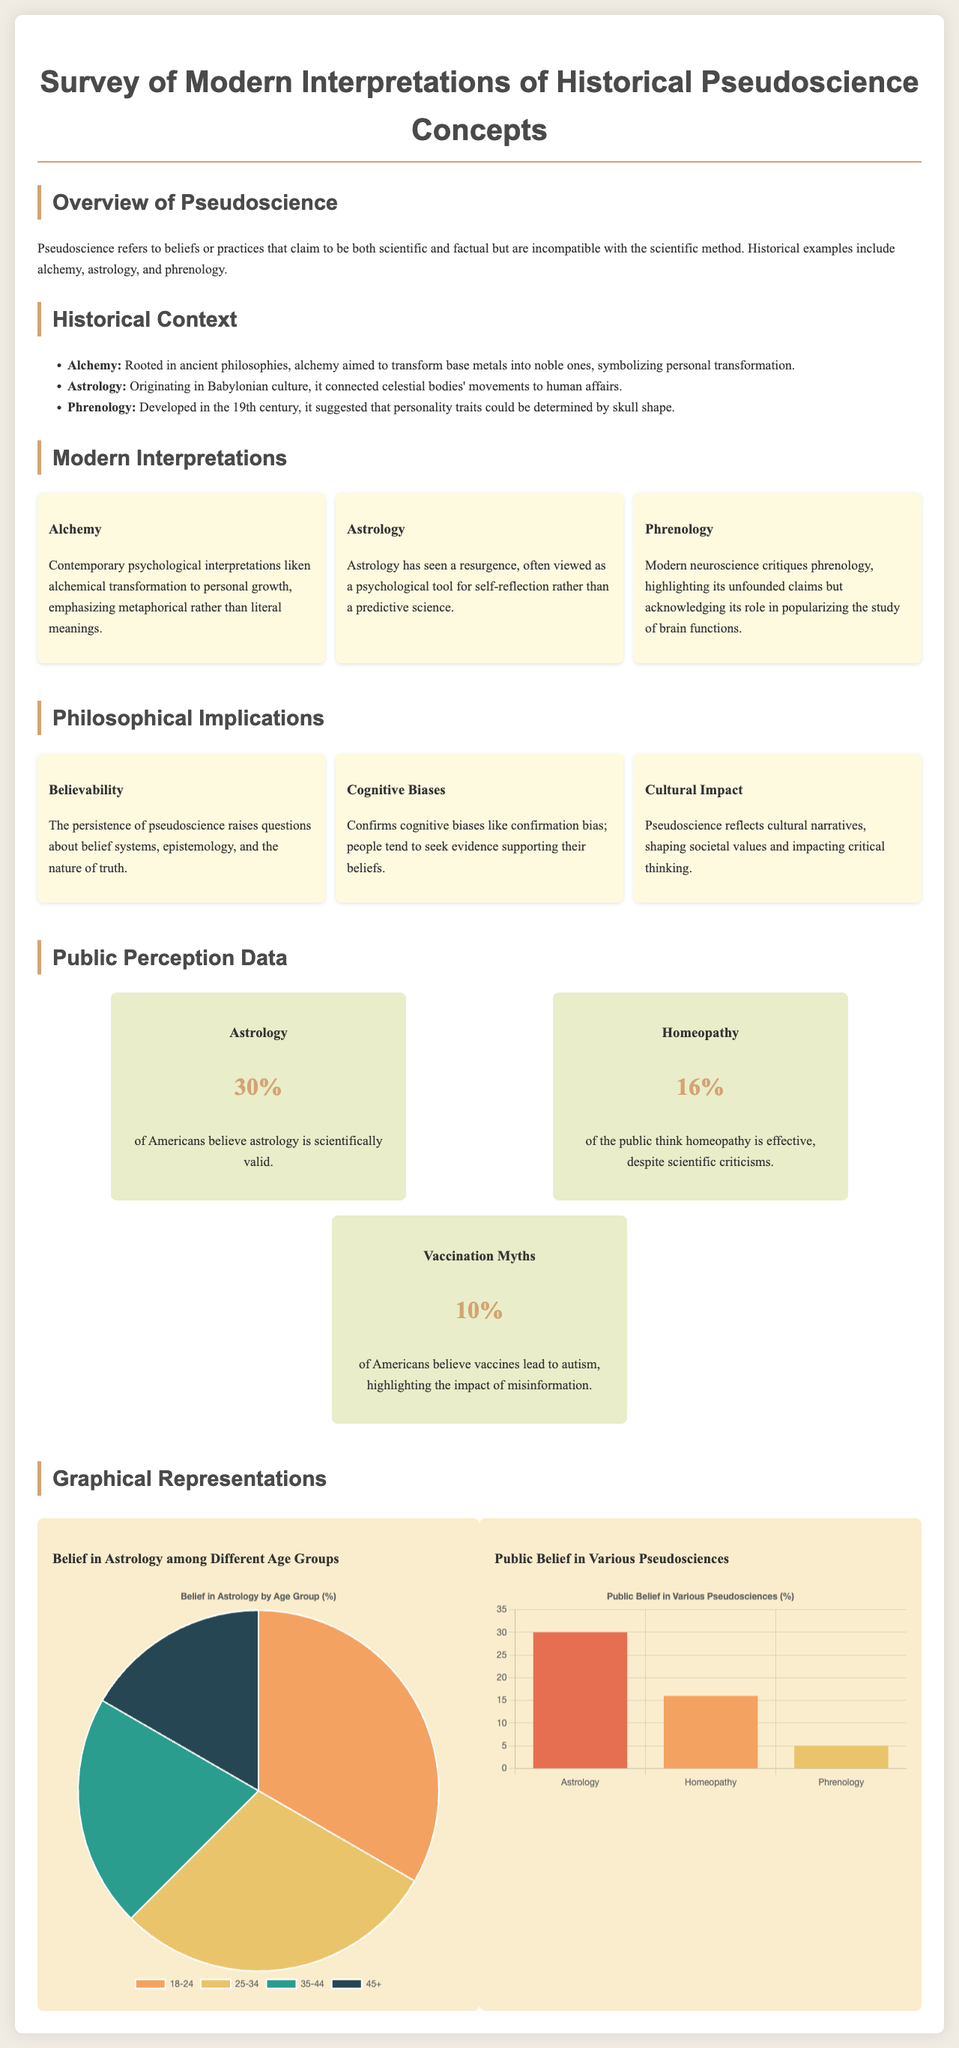What percentage of Americans believe astrology is scientifically valid? The percentage of Americans who believe astrology is scientifically valid is stated in the "Public Perception Data" section.
Answer: 30% What is the belief among Americans regarding homeopathy's effectiveness? The document contains specific information on public belief concerning homeopathy's effectiveness found in the "Public Perception Data" section.
Answer: 16% Which pseudoscience saw a resurgence viewed as a psychological tool? This information can be found in the "Modern Interpretations" section discussing contemporary views of pseudoscience concepts.
Answer: Astrology What cognitive bias is confirmed by the persistence of pseudoscience? The document discusses cognitive biases in the "Philosophical Implications" section, particularly related to belief systems.
Answer: Confirmation bias Which pseudoscience had a reported belief percentage of 10% relating to autism? This specific detail is included in the "Public Perception Data" section that addresses misinformation.
Answer: Vaccination Myths What age group has the highest belief in astrology according to the chart? The "Belief in Astrology by Age Group" chart depicts belief distribution among different age groups.
Answer: 18-24 How many total pseudosciences are specifically mentioned in the document? The document includes several pseudosciences in the "Public Perception Data" and "Modern Interpretations" sections, allowing for this count.
Answer: Three What societal issue is raised by the belief in pseudoscience? The document touches on the impact of pseudoscience on society specifically in the "Philosophical Implications" section.
Answer: Critical thinking 